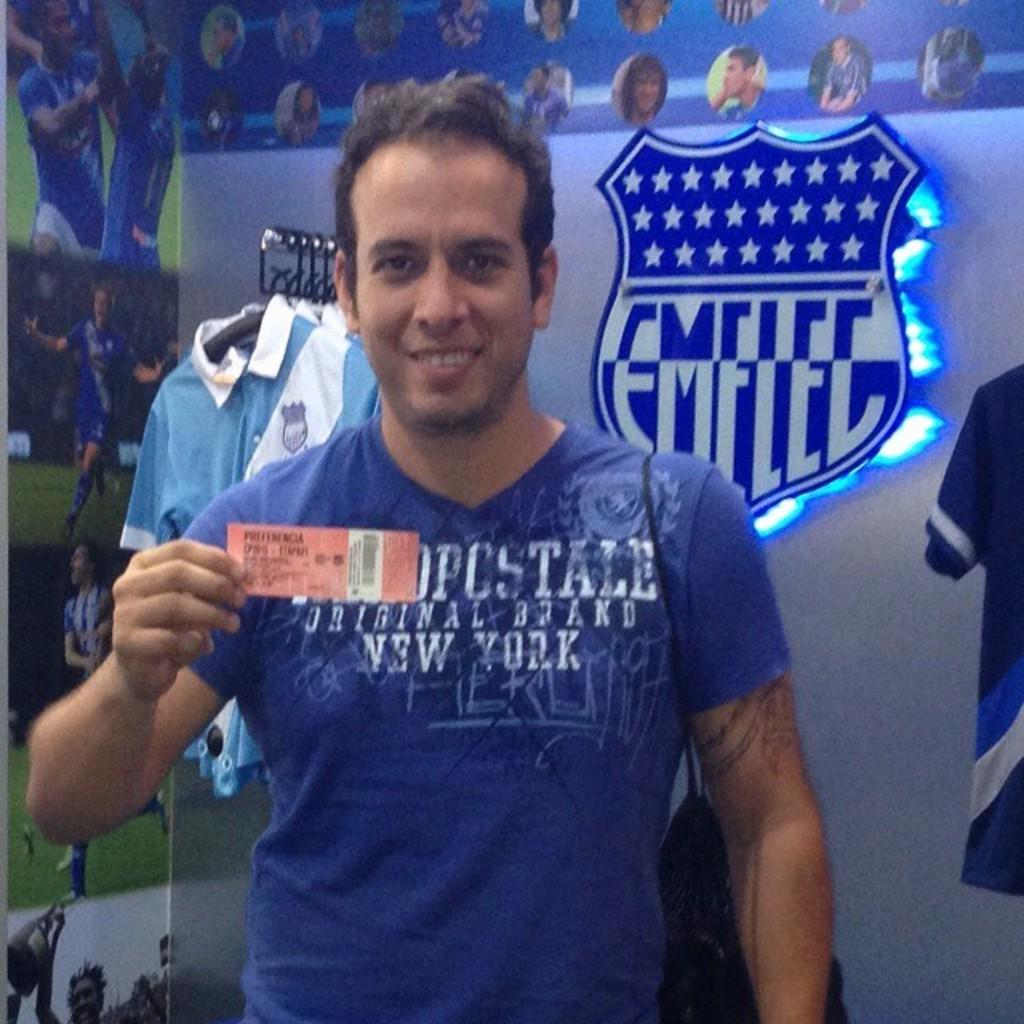<image>
Share a concise interpretation of the image provided. The logo for Emelec is behind a man in a blue new york branded shirt. 